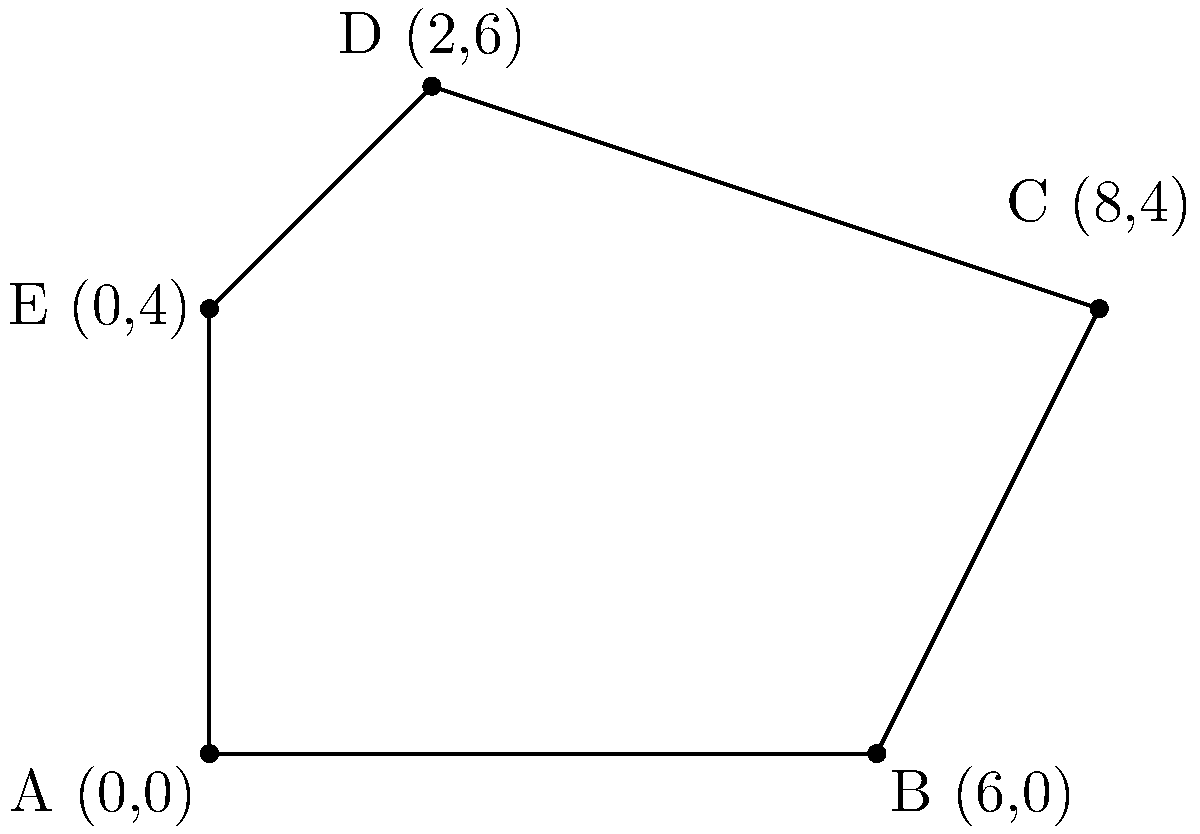As a landowner observing bird habitats, you've noticed an irregular-shaped area frequented by a rare species. The biologist asks you to calculate the area of this habitat using coordinate geometry. The habitat's boundary points are A(0,0), B(6,0), C(8,4), D(2,6), and E(0,4). What is the area of this irregular-shaped bird habitat in square units? To calculate the area of this irregular polygon, we can use the Shoelace formula (also known as the surveyor's formula). The steps are as follows:

1) First, let's arrange the coordinates in order:
   (0,0), (6,0), (8,4), (2,6), (0,4)

2) The Shoelace formula is:
   $$Area = \frac{1}{2}|(x_1y_2 + x_2y_3 + ... + x_ny_1) - (y_1x_2 + y_2x_3 + ... + y_nx_1)|$$

3) Let's apply the formula:
   $$Area = \frac{1}{2}|[(0 \cdot 0) + (6 \cdot 4) + (8 \cdot 6) + (2 \cdot 4) + (0 \cdot 0)]$$
   $$- [(0 \cdot 6) + (0 \cdot 8) + (4 \cdot 2) + (6 \cdot 0) + (4 \cdot 0)]|$$

4) Simplify:
   $$Area = \frac{1}{2}|[0 + 24 + 48 + 8 + 0] - [0 + 0 + 8 + 0 + 0]|$$
   $$= \frac{1}{2}|80 - 8|$$
   $$= \frac{1}{2} \cdot 72$$
   $$= 36$$

Therefore, the area of the irregular-shaped bird habitat is 36 square units.
Answer: 36 square units 